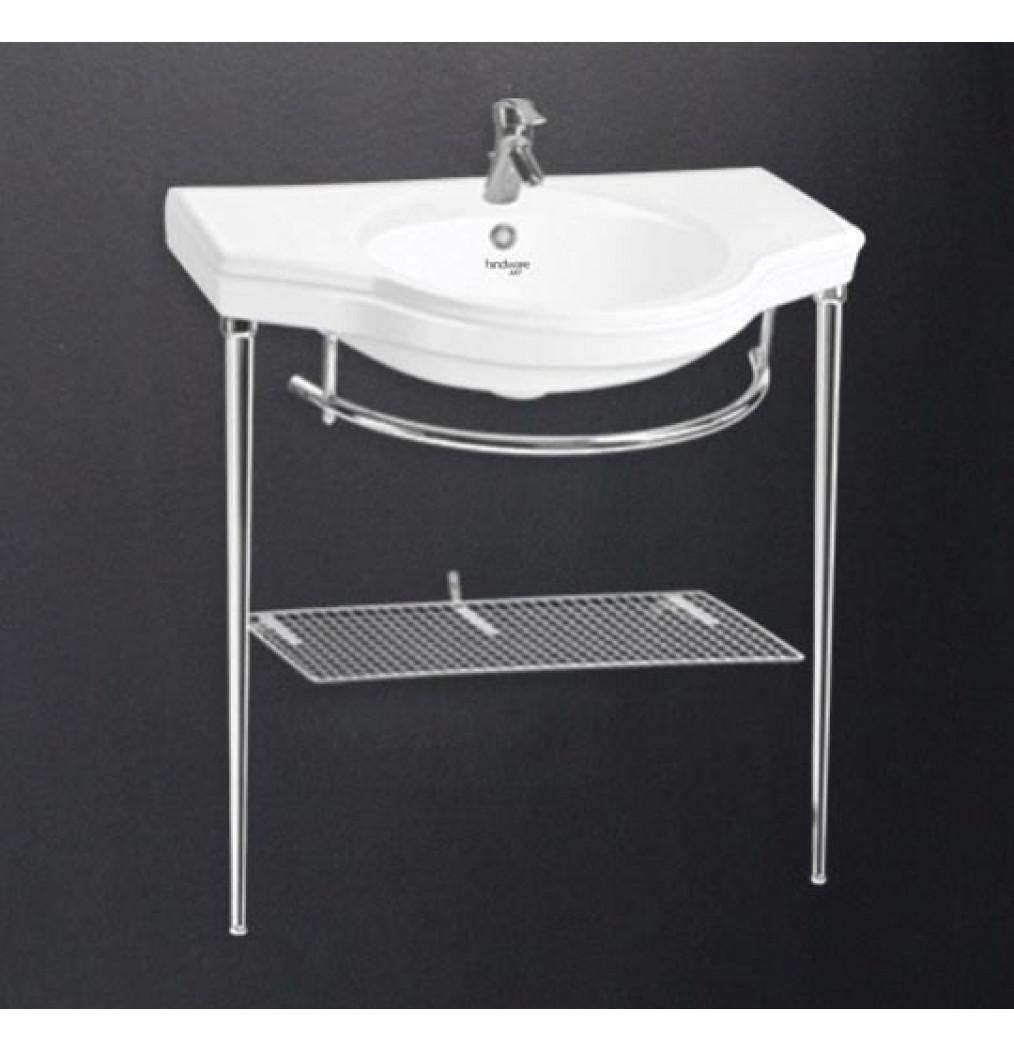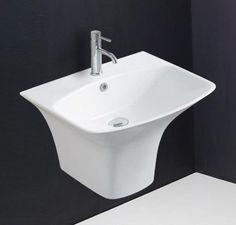The first image is the image on the left, the second image is the image on the right. For the images shown, is this caption "In one of the images, there is a freestanding white sink with a shelf underneath and chrome legs." true? Answer yes or no. Yes. The first image is the image on the left, the second image is the image on the right. Assess this claim about the two images: "There is a shelf under the sink in one of the images.". Correct or not? Answer yes or no. Yes. 